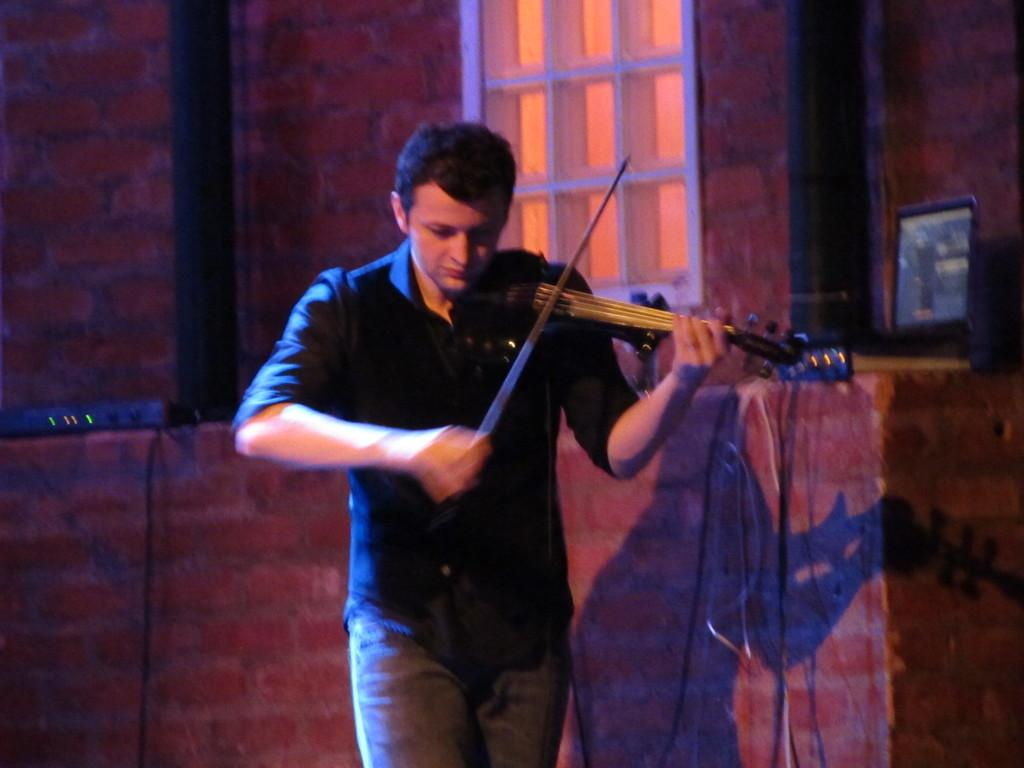What is the main subject of the image? There is a person in the image. What is the person doing in the image? The person is standing and playing a musical instrument. What color is the shirt the person is wearing? The person is wearing a black shirt. What can be seen in the background of the image? There is a wall and a window in the background of the image. What type of vegetable is the person holding in the image? There is no vegetable present in the image; the person is playing a musical instrument. Can you see a robin perched on the person's shoulder in the image? There is no robin present in the image. 